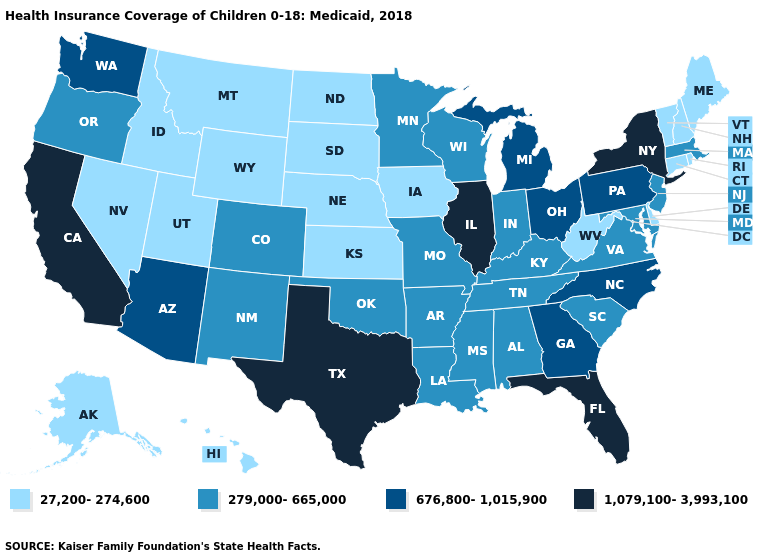Does New Mexico have the highest value in the USA?
Keep it brief. No. Does Pennsylvania have a lower value than California?
Concise answer only. Yes. What is the lowest value in the USA?
Answer briefly. 27,200-274,600. Among the states that border Idaho , which have the lowest value?
Write a very short answer. Montana, Nevada, Utah, Wyoming. Name the states that have a value in the range 27,200-274,600?
Write a very short answer. Alaska, Connecticut, Delaware, Hawaii, Idaho, Iowa, Kansas, Maine, Montana, Nebraska, Nevada, New Hampshire, North Dakota, Rhode Island, South Dakota, Utah, Vermont, West Virginia, Wyoming. Which states have the highest value in the USA?
Quick response, please. California, Florida, Illinois, New York, Texas. Name the states that have a value in the range 1,079,100-3,993,100?
Keep it brief. California, Florida, Illinois, New York, Texas. What is the lowest value in the MidWest?
Write a very short answer. 27,200-274,600. What is the lowest value in states that border Maryland?
Concise answer only. 27,200-274,600. Name the states that have a value in the range 27,200-274,600?
Quick response, please. Alaska, Connecticut, Delaware, Hawaii, Idaho, Iowa, Kansas, Maine, Montana, Nebraska, Nevada, New Hampshire, North Dakota, Rhode Island, South Dakota, Utah, Vermont, West Virginia, Wyoming. What is the value of North Carolina?
Concise answer only. 676,800-1,015,900. What is the highest value in the USA?
Short answer required. 1,079,100-3,993,100. Does the first symbol in the legend represent the smallest category?
Keep it brief. Yes. Among the states that border Illinois , does Iowa have the lowest value?
Quick response, please. Yes. Does Delaware have the highest value in the South?
Write a very short answer. No. 